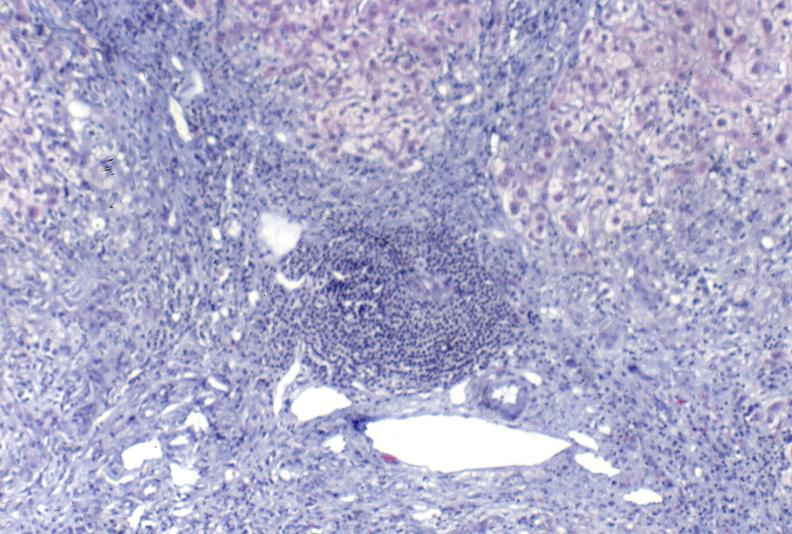s immunostain for growth hormone present?
Answer the question using a single word or phrase. No 